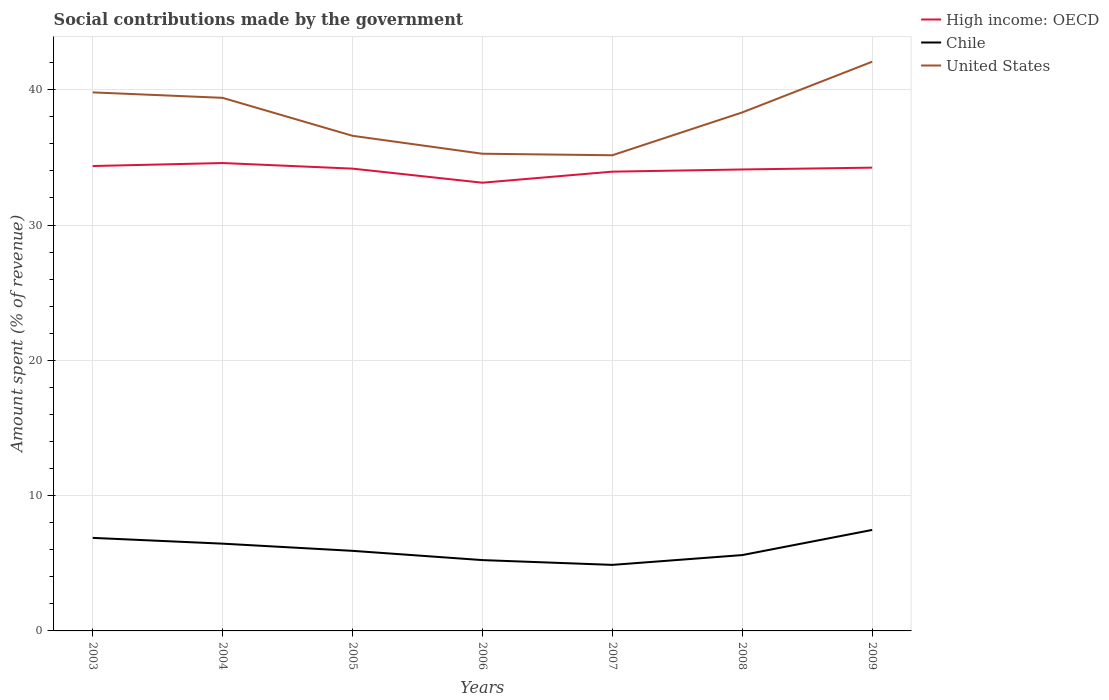Does the line corresponding to United States intersect with the line corresponding to Chile?
Offer a terse response. No. Is the number of lines equal to the number of legend labels?
Offer a terse response. Yes. Across all years, what is the maximum amount spent (in %) on social contributions in United States?
Ensure brevity in your answer.  35.16. In which year was the amount spent (in %) on social contributions in United States maximum?
Give a very brief answer. 2007. What is the total amount spent (in %) on social contributions in High income: OECD in the graph?
Give a very brief answer. 0.42. What is the difference between the highest and the second highest amount spent (in %) on social contributions in United States?
Keep it short and to the point. 6.91. What is the difference between the highest and the lowest amount spent (in %) on social contributions in High income: OECD?
Your answer should be compact. 5. Is the amount spent (in %) on social contributions in Chile strictly greater than the amount spent (in %) on social contributions in High income: OECD over the years?
Your response must be concise. Yes. How many lines are there?
Provide a succinct answer. 3. How many years are there in the graph?
Make the answer very short. 7. What is the difference between two consecutive major ticks on the Y-axis?
Provide a succinct answer. 10. Are the values on the major ticks of Y-axis written in scientific E-notation?
Your answer should be very brief. No. Does the graph contain any zero values?
Your answer should be very brief. No. How are the legend labels stacked?
Offer a very short reply. Vertical. What is the title of the graph?
Provide a succinct answer. Social contributions made by the government. Does "Ghana" appear as one of the legend labels in the graph?
Ensure brevity in your answer.  No. What is the label or title of the Y-axis?
Provide a short and direct response. Amount spent (% of revenue). What is the Amount spent (% of revenue) of High income: OECD in 2003?
Give a very brief answer. 34.36. What is the Amount spent (% of revenue) in Chile in 2003?
Offer a terse response. 6.88. What is the Amount spent (% of revenue) in United States in 2003?
Offer a very short reply. 39.8. What is the Amount spent (% of revenue) in High income: OECD in 2004?
Give a very brief answer. 34.58. What is the Amount spent (% of revenue) of Chile in 2004?
Offer a very short reply. 6.45. What is the Amount spent (% of revenue) in United States in 2004?
Offer a terse response. 39.4. What is the Amount spent (% of revenue) in High income: OECD in 2005?
Your answer should be very brief. 34.17. What is the Amount spent (% of revenue) in Chile in 2005?
Your response must be concise. 5.92. What is the Amount spent (% of revenue) of United States in 2005?
Make the answer very short. 36.59. What is the Amount spent (% of revenue) of High income: OECD in 2006?
Make the answer very short. 33.13. What is the Amount spent (% of revenue) of Chile in 2006?
Ensure brevity in your answer.  5.23. What is the Amount spent (% of revenue) of United States in 2006?
Make the answer very short. 35.27. What is the Amount spent (% of revenue) of High income: OECD in 2007?
Your answer should be compact. 33.94. What is the Amount spent (% of revenue) in Chile in 2007?
Ensure brevity in your answer.  4.88. What is the Amount spent (% of revenue) in United States in 2007?
Ensure brevity in your answer.  35.16. What is the Amount spent (% of revenue) of High income: OECD in 2008?
Your answer should be compact. 34.1. What is the Amount spent (% of revenue) in Chile in 2008?
Offer a terse response. 5.61. What is the Amount spent (% of revenue) of United States in 2008?
Your answer should be very brief. 38.32. What is the Amount spent (% of revenue) of High income: OECD in 2009?
Make the answer very short. 34.24. What is the Amount spent (% of revenue) of Chile in 2009?
Keep it short and to the point. 7.46. What is the Amount spent (% of revenue) of United States in 2009?
Ensure brevity in your answer.  42.07. Across all years, what is the maximum Amount spent (% of revenue) in High income: OECD?
Offer a terse response. 34.58. Across all years, what is the maximum Amount spent (% of revenue) in Chile?
Ensure brevity in your answer.  7.46. Across all years, what is the maximum Amount spent (% of revenue) in United States?
Provide a short and direct response. 42.07. Across all years, what is the minimum Amount spent (% of revenue) in High income: OECD?
Your answer should be compact. 33.13. Across all years, what is the minimum Amount spent (% of revenue) of Chile?
Offer a very short reply. 4.88. Across all years, what is the minimum Amount spent (% of revenue) of United States?
Provide a short and direct response. 35.16. What is the total Amount spent (% of revenue) of High income: OECD in the graph?
Give a very brief answer. 238.52. What is the total Amount spent (% of revenue) in Chile in the graph?
Keep it short and to the point. 42.43. What is the total Amount spent (% of revenue) of United States in the graph?
Your answer should be very brief. 266.6. What is the difference between the Amount spent (% of revenue) of High income: OECD in 2003 and that in 2004?
Offer a terse response. -0.22. What is the difference between the Amount spent (% of revenue) of Chile in 2003 and that in 2004?
Provide a short and direct response. 0.43. What is the difference between the Amount spent (% of revenue) in United States in 2003 and that in 2004?
Make the answer very short. 0.4. What is the difference between the Amount spent (% of revenue) of High income: OECD in 2003 and that in 2005?
Provide a succinct answer. 0.19. What is the difference between the Amount spent (% of revenue) in Chile in 2003 and that in 2005?
Provide a short and direct response. 0.96. What is the difference between the Amount spent (% of revenue) in United States in 2003 and that in 2005?
Give a very brief answer. 3.21. What is the difference between the Amount spent (% of revenue) in High income: OECD in 2003 and that in 2006?
Your response must be concise. 1.23. What is the difference between the Amount spent (% of revenue) of Chile in 2003 and that in 2006?
Your answer should be compact. 1.64. What is the difference between the Amount spent (% of revenue) of United States in 2003 and that in 2006?
Your response must be concise. 4.53. What is the difference between the Amount spent (% of revenue) of High income: OECD in 2003 and that in 2007?
Provide a succinct answer. 0.42. What is the difference between the Amount spent (% of revenue) of Chile in 2003 and that in 2007?
Your response must be concise. 2. What is the difference between the Amount spent (% of revenue) of United States in 2003 and that in 2007?
Your response must be concise. 4.65. What is the difference between the Amount spent (% of revenue) of High income: OECD in 2003 and that in 2008?
Make the answer very short. 0.25. What is the difference between the Amount spent (% of revenue) in Chile in 2003 and that in 2008?
Make the answer very short. 1.27. What is the difference between the Amount spent (% of revenue) in United States in 2003 and that in 2008?
Provide a succinct answer. 1.48. What is the difference between the Amount spent (% of revenue) of High income: OECD in 2003 and that in 2009?
Give a very brief answer. 0.12. What is the difference between the Amount spent (% of revenue) in Chile in 2003 and that in 2009?
Provide a succinct answer. -0.59. What is the difference between the Amount spent (% of revenue) in United States in 2003 and that in 2009?
Offer a terse response. -2.27. What is the difference between the Amount spent (% of revenue) in High income: OECD in 2004 and that in 2005?
Give a very brief answer. 0.41. What is the difference between the Amount spent (% of revenue) of Chile in 2004 and that in 2005?
Your answer should be very brief. 0.53. What is the difference between the Amount spent (% of revenue) in United States in 2004 and that in 2005?
Your response must be concise. 2.81. What is the difference between the Amount spent (% of revenue) in High income: OECD in 2004 and that in 2006?
Give a very brief answer. 1.45. What is the difference between the Amount spent (% of revenue) in Chile in 2004 and that in 2006?
Provide a short and direct response. 1.22. What is the difference between the Amount spent (% of revenue) of United States in 2004 and that in 2006?
Offer a very short reply. 4.13. What is the difference between the Amount spent (% of revenue) of High income: OECD in 2004 and that in 2007?
Your response must be concise. 0.64. What is the difference between the Amount spent (% of revenue) in Chile in 2004 and that in 2007?
Keep it short and to the point. 1.57. What is the difference between the Amount spent (% of revenue) in United States in 2004 and that in 2007?
Your answer should be very brief. 4.24. What is the difference between the Amount spent (% of revenue) in High income: OECD in 2004 and that in 2008?
Provide a short and direct response. 0.48. What is the difference between the Amount spent (% of revenue) of Chile in 2004 and that in 2008?
Keep it short and to the point. 0.84. What is the difference between the Amount spent (% of revenue) of United States in 2004 and that in 2008?
Your answer should be compact. 1.08. What is the difference between the Amount spent (% of revenue) in High income: OECD in 2004 and that in 2009?
Give a very brief answer. 0.34. What is the difference between the Amount spent (% of revenue) of Chile in 2004 and that in 2009?
Make the answer very short. -1.01. What is the difference between the Amount spent (% of revenue) in United States in 2004 and that in 2009?
Your response must be concise. -2.67. What is the difference between the Amount spent (% of revenue) of High income: OECD in 2005 and that in 2006?
Offer a terse response. 1.04. What is the difference between the Amount spent (% of revenue) of Chile in 2005 and that in 2006?
Offer a terse response. 0.68. What is the difference between the Amount spent (% of revenue) of United States in 2005 and that in 2006?
Give a very brief answer. 1.33. What is the difference between the Amount spent (% of revenue) of High income: OECD in 2005 and that in 2007?
Your answer should be compact. 0.22. What is the difference between the Amount spent (% of revenue) in Chile in 2005 and that in 2007?
Make the answer very short. 1.04. What is the difference between the Amount spent (% of revenue) in United States in 2005 and that in 2007?
Give a very brief answer. 1.44. What is the difference between the Amount spent (% of revenue) of High income: OECD in 2005 and that in 2008?
Provide a short and direct response. 0.06. What is the difference between the Amount spent (% of revenue) in Chile in 2005 and that in 2008?
Provide a short and direct response. 0.31. What is the difference between the Amount spent (% of revenue) in United States in 2005 and that in 2008?
Offer a terse response. -1.73. What is the difference between the Amount spent (% of revenue) in High income: OECD in 2005 and that in 2009?
Your answer should be very brief. -0.07. What is the difference between the Amount spent (% of revenue) of Chile in 2005 and that in 2009?
Give a very brief answer. -1.54. What is the difference between the Amount spent (% of revenue) in United States in 2005 and that in 2009?
Ensure brevity in your answer.  -5.47. What is the difference between the Amount spent (% of revenue) of High income: OECD in 2006 and that in 2007?
Provide a succinct answer. -0.82. What is the difference between the Amount spent (% of revenue) in Chile in 2006 and that in 2007?
Your answer should be very brief. 0.35. What is the difference between the Amount spent (% of revenue) of United States in 2006 and that in 2007?
Your response must be concise. 0.11. What is the difference between the Amount spent (% of revenue) in High income: OECD in 2006 and that in 2008?
Offer a terse response. -0.98. What is the difference between the Amount spent (% of revenue) of Chile in 2006 and that in 2008?
Offer a terse response. -0.37. What is the difference between the Amount spent (% of revenue) of United States in 2006 and that in 2008?
Ensure brevity in your answer.  -3.05. What is the difference between the Amount spent (% of revenue) of High income: OECD in 2006 and that in 2009?
Your answer should be very brief. -1.11. What is the difference between the Amount spent (% of revenue) in Chile in 2006 and that in 2009?
Ensure brevity in your answer.  -2.23. What is the difference between the Amount spent (% of revenue) in United States in 2006 and that in 2009?
Offer a very short reply. -6.8. What is the difference between the Amount spent (% of revenue) in High income: OECD in 2007 and that in 2008?
Your response must be concise. -0.16. What is the difference between the Amount spent (% of revenue) of Chile in 2007 and that in 2008?
Your answer should be compact. -0.72. What is the difference between the Amount spent (% of revenue) of United States in 2007 and that in 2008?
Offer a terse response. -3.16. What is the difference between the Amount spent (% of revenue) of High income: OECD in 2007 and that in 2009?
Provide a succinct answer. -0.3. What is the difference between the Amount spent (% of revenue) in Chile in 2007 and that in 2009?
Give a very brief answer. -2.58. What is the difference between the Amount spent (% of revenue) in United States in 2007 and that in 2009?
Offer a very short reply. -6.91. What is the difference between the Amount spent (% of revenue) in High income: OECD in 2008 and that in 2009?
Your answer should be compact. -0.13. What is the difference between the Amount spent (% of revenue) in Chile in 2008 and that in 2009?
Ensure brevity in your answer.  -1.86. What is the difference between the Amount spent (% of revenue) in United States in 2008 and that in 2009?
Provide a succinct answer. -3.75. What is the difference between the Amount spent (% of revenue) in High income: OECD in 2003 and the Amount spent (% of revenue) in Chile in 2004?
Your response must be concise. 27.91. What is the difference between the Amount spent (% of revenue) in High income: OECD in 2003 and the Amount spent (% of revenue) in United States in 2004?
Your response must be concise. -5.04. What is the difference between the Amount spent (% of revenue) in Chile in 2003 and the Amount spent (% of revenue) in United States in 2004?
Give a very brief answer. -32.52. What is the difference between the Amount spent (% of revenue) of High income: OECD in 2003 and the Amount spent (% of revenue) of Chile in 2005?
Your answer should be very brief. 28.44. What is the difference between the Amount spent (% of revenue) of High income: OECD in 2003 and the Amount spent (% of revenue) of United States in 2005?
Provide a succinct answer. -2.23. What is the difference between the Amount spent (% of revenue) in Chile in 2003 and the Amount spent (% of revenue) in United States in 2005?
Ensure brevity in your answer.  -29.72. What is the difference between the Amount spent (% of revenue) in High income: OECD in 2003 and the Amount spent (% of revenue) in Chile in 2006?
Offer a very short reply. 29.12. What is the difference between the Amount spent (% of revenue) in High income: OECD in 2003 and the Amount spent (% of revenue) in United States in 2006?
Provide a succinct answer. -0.91. What is the difference between the Amount spent (% of revenue) of Chile in 2003 and the Amount spent (% of revenue) of United States in 2006?
Make the answer very short. -28.39. What is the difference between the Amount spent (% of revenue) of High income: OECD in 2003 and the Amount spent (% of revenue) of Chile in 2007?
Offer a terse response. 29.48. What is the difference between the Amount spent (% of revenue) of High income: OECD in 2003 and the Amount spent (% of revenue) of United States in 2007?
Your answer should be compact. -0.8. What is the difference between the Amount spent (% of revenue) in Chile in 2003 and the Amount spent (% of revenue) in United States in 2007?
Your response must be concise. -28.28. What is the difference between the Amount spent (% of revenue) of High income: OECD in 2003 and the Amount spent (% of revenue) of Chile in 2008?
Offer a terse response. 28.75. What is the difference between the Amount spent (% of revenue) in High income: OECD in 2003 and the Amount spent (% of revenue) in United States in 2008?
Offer a terse response. -3.96. What is the difference between the Amount spent (% of revenue) in Chile in 2003 and the Amount spent (% of revenue) in United States in 2008?
Your response must be concise. -31.44. What is the difference between the Amount spent (% of revenue) in High income: OECD in 2003 and the Amount spent (% of revenue) in Chile in 2009?
Keep it short and to the point. 26.89. What is the difference between the Amount spent (% of revenue) of High income: OECD in 2003 and the Amount spent (% of revenue) of United States in 2009?
Provide a short and direct response. -7.71. What is the difference between the Amount spent (% of revenue) of Chile in 2003 and the Amount spent (% of revenue) of United States in 2009?
Ensure brevity in your answer.  -35.19. What is the difference between the Amount spent (% of revenue) in High income: OECD in 2004 and the Amount spent (% of revenue) in Chile in 2005?
Your answer should be very brief. 28.66. What is the difference between the Amount spent (% of revenue) of High income: OECD in 2004 and the Amount spent (% of revenue) of United States in 2005?
Keep it short and to the point. -2.01. What is the difference between the Amount spent (% of revenue) of Chile in 2004 and the Amount spent (% of revenue) of United States in 2005?
Keep it short and to the point. -30.14. What is the difference between the Amount spent (% of revenue) of High income: OECD in 2004 and the Amount spent (% of revenue) of Chile in 2006?
Make the answer very short. 29.35. What is the difference between the Amount spent (% of revenue) in High income: OECD in 2004 and the Amount spent (% of revenue) in United States in 2006?
Your response must be concise. -0.69. What is the difference between the Amount spent (% of revenue) in Chile in 2004 and the Amount spent (% of revenue) in United States in 2006?
Keep it short and to the point. -28.82. What is the difference between the Amount spent (% of revenue) in High income: OECD in 2004 and the Amount spent (% of revenue) in Chile in 2007?
Your response must be concise. 29.7. What is the difference between the Amount spent (% of revenue) in High income: OECD in 2004 and the Amount spent (% of revenue) in United States in 2007?
Ensure brevity in your answer.  -0.57. What is the difference between the Amount spent (% of revenue) in Chile in 2004 and the Amount spent (% of revenue) in United States in 2007?
Provide a succinct answer. -28.71. What is the difference between the Amount spent (% of revenue) of High income: OECD in 2004 and the Amount spent (% of revenue) of Chile in 2008?
Provide a short and direct response. 28.97. What is the difference between the Amount spent (% of revenue) in High income: OECD in 2004 and the Amount spent (% of revenue) in United States in 2008?
Ensure brevity in your answer.  -3.74. What is the difference between the Amount spent (% of revenue) in Chile in 2004 and the Amount spent (% of revenue) in United States in 2008?
Your answer should be compact. -31.87. What is the difference between the Amount spent (% of revenue) in High income: OECD in 2004 and the Amount spent (% of revenue) in Chile in 2009?
Make the answer very short. 27.12. What is the difference between the Amount spent (% of revenue) in High income: OECD in 2004 and the Amount spent (% of revenue) in United States in 2009?
Your answer should be very brief. -7.49. What is the difference between the Amount spent (% of revenue) of Chile in 2004 and the Amount spent (% of revenue) of United States in 2009?
Keep it short and to the point. -35.62. What is the difference between the Amount spent (% of revenue) of High income: OECD in 2005 and the Amount spent (% of revenue) of Chile in 2006?
Offer a very short reply. 28.93. What is the difference between the Amount spent (% of revenue) in High income: OECD in 2005 and the Amount spent (% of revenue) in United States in 2006?
Your response must be concise. -1.1. What is the difference between the Amount spent (% of revenue) of Chile in 2005 and the Amount spent (% of revenue) of United States in 2006?
Provide a short and direct response. -29.35. What is the difference between the Amount spent (% of revenue) of High income: OECD in 2005 and the Amount spent (% of revenue) of Chile in 2007?
Your answer should be compact. 29.29. What is the difference between the Amount spent (% of revenue) of High income: OECD in 2005 and the Amount spent (% of revenue) of United States in 2007?
Make the answer very short. -0.99. What is the difference between the Amount spent (% of revenue) of Chile in 2005 and the Amount spent (% of revenue) of United States in 2007?
Offer a terse response. -29.24. What is the difference between the Amount spent (% of revenue) of High income: OECD in 2005 and the Amount spent (% of revenue) of Chile in 2008?
Offer a terse response. 28.56. What is the difference between the Amount spent (% of revenue) of High income: OECD in 2005 and the Amount spent (% of revenue) of United States in 2008?
Give a very brief answer. -4.15. What is the difference between the Amount spent (% of revenue) of Chile in 2005 and the Amount spent (% of revenue) of United States in 2008?
Make the answer very short. -32.4. What is the difference between the Amount spent (% of revenue) in High income: OECD in 2005 and the Amount spent (% of revenue) in Chile in 2009?
Offer a terse response. 26.7. What is the difference between the Amount spent (% of revenue) of High income: OECD in 2005 and the Amount spent (% of revenue) of United States in 2009?
Offer a very short reply. -7.9. What is the difference between the Amount spent (% of revenue) of Chile in 2005 and the Amount spent (% of revenue) of United States in 2009?
Ensure brevity in your answer.  -36.15. What is the difference between the Amount spent (% of revenue) of High income: OECD in 2006 and the Amount spent (% of revenue) of Chile in 2007?
Provide a succinct answer. 28.25. What is the difference between the Amount spent (% of revenue) of High income: OECD in 2006 and the Amount spent (% of revenue) of United States in 2007?
Provide a short and direct response. -2.03. What is the difference between the Amount spent (% of revenue) in Chile in 2006 and the Amount spent (% of revenue) in United States in 2007?
Offer a terse response. -29.92. What is the difference between the Amount spent (% of revenue) of High income: OECD in 2006 and the Amount spent (% of revenue) of Chile in 2008?
Give a very brief answer. 27.52. What is the difference between the Amount spent (% of revenue) in High income: OECD in 2006 and the Amount spent (% of revenue) in United States in 2008?
Your response must be concise. -5.19. What is the difference between the Amount spent (% of revenue) in Chile in 2006 and the Amount spent (% of revenue) in United States in 2008?
Keep it short and to the point. -33.09. What is the difference between the Amount spent (% of revenue) in High income: OECD in 2006 and the Amount spent (% of revenue) in Chile in 2009?
Keep it short and to the point. 25.66. What is the difference between the Amount spent (% of revenue) in High income: OECD in 2006 and the Amount spent (% of revenue) in United States in 2009?
Your response must be concise. -8.94. What is the difference between the Amount spent (% of revenue) of Chile in 2006 and the Amount spent (% of revenue) of United States in 2009?
Your answer should be compact. -36.83. What is the difference between the Amount spent (% of revenue) in High income: OECD in 2007 and the Amount spent (% of revenue) in Chile in 2008?
Offer a terse response. 28.34. What is the difference between the Amount spent (% of revenue) in High income: OECD in 2007 and the Amount spent (% of revenue) in United States in 2008?
Your response must be concise. -4.38. What is the difference between the Amount spent (% of revenue) of Chile in 2007 and the Amount spent (% of revenue) of United States in 2008?
Your response must be concise. -33.44. What is the difference between the Amount spent (% of revenue) of High income: OECD in 2007 and the Amount spent (% of revenue) of Chile in 2009?
Make the answer very short. 26.48. What is the difference between the Amount spent (% of revenue) in High income: OECD in 2007 and the Amount spent (% of revenue) in United States in 2009?
Make the answer very short. -8.12. What is the difference between the Amount spent (% of revenue) in Chile in 2007 and the Amount spent (% of revenue) in United States in 2009?
Your answer should be very brief. -37.19. What is the difference between the Amount spent (% of revenue) of High income: OECD in 2008 and the Amount spent (% of revenue) of Chile in 2009?
Make the answer very short. 26.64. What is the difference between the Amount spent (% of revenue) of High income: OECD in 2008 and the Amount spent (% of revenue) of United States in 2009?
Your answer should be very brief. -7.96. What is the difference between the Amount spent (% of revenue) in Chile in 2008 and the Amount spent (% of revenue) in United States in 2009?
Your answer should be very brief. -36.46. What is the average Amount spent (% of revenue) in High income: OECD per year?
Provide a succinct answer. 34.07. What is the average Amount spent (% of revenue) of Chile per year?
Your answer should be compact. 6.06. What is the average Amount spent (% of revenue) in United States per year?
Your answer should be compact. 38.09. In the year 2003, what is the difference between the Amount spent (% of revenue) in High income: OECD and Amount spent (% of revenue) in Chile?
Ensure brevity in your answer.  27.48. In the year 2003, what is the difference between the Amount spent (% of revenue) in High income: OECD and Amount spent (% of revenue) in United States?
Offer a terse response. -5.44. In the year 2003, what is the difference between the Amount spent (% of revenue) of Chile and Amount spent (% of revenue) of United States?
Provide a succinct answer. -32.93. In the year 2004, what is the difference between the Amount spent (% of revenue) of High income: OECD and Amount spent (% of revenue) of Chile?
Offer a very short reply. 28.13. In the year 2004, what is the difference between the Amount spent (% of revenue) of High income: OECD and Amount spent (% of revenue) of United States?
Your response must be concise. -4.82. In the year 2004, what is the difference between the Amount spent (% of revenue) in Chile and Amount spent (% of revenue) in United States?
Keep it short and to the point. -32.95. In the year 2005, what is the difference between the Amount spent (% of revenue) in High income: OECD and Amount spent (% of revenue) in Chile?
Provide a succinct answer. 28.25. In the year 2005, what is the difference between the Amount spent (% of revenue) in High income: OECD and Amount spent (% of revenue) in United States?
Ensure brevity in your answer.  -2.43. In the year 2005, what is the difference between the Amount spent (% of revenue) in Chile and Amount spent (% of revenue) in United States?
Ensure brevity in your answer.  -30.67. In the year 2006, what is the difference between the Amount spent (% of revenue) of High income: OECD and Amount spent (% of revenue) of Chile?
Your response must be concise. 27.89. In the year 2006, what is the difference between the Amount spent (% of revenue) in High income: OECD and Amount spent (% of revenue) in United States?
Your answer should be very brief. -2.14. In the year 2006, what is the difference between the Amount spent (% of revenue) in Chile and Amount spent (% of revenue) in United States?
Make the answer very short. -30.03. In the year 2007, what is the difference between the Amount spent (% of revenue) in High income: OECD and Amount spent (% of revenue) in Chile?
Provide a succinct answer. 29.06. In the year 2007, what is the difference between the Amount spent (% of revenue) in High income: OECD and Amount spent (% of revenue) in United States?
Provide a succinct answer. -1.21. In the year 2007, what is the difference between the Amount spent (% of revenue) in Chile and Amount spent (% of revenue) in United States?
Provide a succinct answer. -30.27. In the year 2008, what is the difference between the Amount spent (% of revenue) in High income: OECD and Amount spent (% of revenue) in Chile?
Offer a very short reply. 28.5. In the year 2008, what is the difference between the Amount spent (% of revenue) in High income: OECD and Amount spent (% of revenue) in United States?
Provide a short and direct response. -4.21. In the year 2008, what is the difference between the Amount spent (% of revenue) of Chile and Amount spent (% of revenue) of United States?
Give a very brief answer. -32.71. In the year 2009, what is the difference between the Amount spent (% of revenue) of High income: OECD and Amount spent (% of revenue) of Chile?
Your answer should be very brief. 26.78. In the year 2009, what is the difference between the Amount spent (% of revenue) in High income: OECD and Amount spent (% of revenue) in United States?
Give a very brief answer. -7.83. In the year 2009, what is the difference between the Amount spent (% of revenue) of Chile and Amount spent (% of revenue) of United States?
Keep it short and to the point. -34.6. What is the ratio of the Amount spent (% of revenue) of High income: OECD in 2003 to that in 2004?
Your answer should be compact. 0.99. What is the ratio of the Amount spent (% of revenue) of Chile in 2003 to that in 2004?
Provide a short and direct response. 1.07. What is the ratio of the Amount spent (% of revenue) in United States in 2003 to that in 2004?
Your response must be concise. 1.01. What is the ratio of the Amount spent (% of revenue) in High income: OECD in 2003 to that in 2005?
Give a very brief answer. 1.01. What is the ratio of the Amount spent (% of revenue) of Chile in 2003 to that in 2005?
Your answer should be very brief. 1.16. What is the ratio of the Amount spent (% of revenue) of United States in 2003 to that in 2005?
Offer a very short reply. 1.09. What is the ratio of the Amount spent (% of revenue) of High income: OECD in 2003 to that in 2006?
Provide a short and direct response. 1.04. What is the ratio of the Amount spent (% of revenue) in Chile in 2003 to that in 2006?
Your answer should be very brief. 1.31. What is the ratio of the Amount spent (% of revenue) in United States in 2003 to that in 2006?
Offer a terse response. 1.13. What is the ratio of the Amount spent (% of revenue) in High income: OECD in 2003 to that in 2007?
Offer a very short reply. 1.01. What is the ratio of the Amount spent (% of revenue) in Chile in 2003 to that in 2007?
Provide a succinct answer. 1.41. What is the ratio of the Amount spent (% of revenue) in United States in 2003 to that in 2007?
Provide a short and direct response. 1.13. What is the ratio of the Amount spent (% of revenue) of High income: OECD in 2003 to that in 2008?
Provide a short and direct response. 1.01. What is the ratio of the Amount spent (% of revenue) in Chile in 2003 to that in 2008?
Your answer should be compact. 1.23. What is the ratio of the Amount spent (% of revenue) of United States in 2003 to that in 2008?
Provide a succinct answer. 1.04. What is the ratio of the Amount spent (% of revenue) in High income: OECD in 2003 to that in 2009?
Offer a very short reply. 1. What is the ratio of the Amount spent (% of revenue) of Chile in 2003 to that in 2009?
Your answer should be very brief. 0.92. What is the ratio of the Amount spent (% of revenue) of United States in 2003 to that in 2009?
Keep it short and to the point. 0.95. What is the ratio of the Amount spent (% of revenue) of High income: OECD in 2004 to that in 2005?
Provide a succinct answer. 1.01. What is the ratio of the Amount spent (% of revenue) of Chile in 2004 to that in 2005?
Give a very brief answer. 1.09. What is the ratio of the Amount spent (% of revenue) of United States in 2004 to that in 2005?
Your response must be concise. 1.08. What is the ratio of the Amount spent (% of revenue) of High income: OECD in 2004 to that in 2006?
Offer a terse response. 1.04. What is the ratio of the Amount spent (% of revenue) of Chile in 2004 to that in 2006?
Give a very brief answer. 1.23. What is the ratio of the Amount spent (% of revenue) of United States in 2004 to that in 2006?
Provide a succinct answer. 1.12. What is the ratio of the Amount spent (% of revenue) of High income: OECD in 2004 to that in 2007?
Give a very brief answer. 1.02. What is the ratio of the Amount spent (% of revenue) in Chile in 2004 to that in 2007?
Provide a short and direct response. 1.32. What is the ratio of the Amount spent (% of revenue) in United States in 2004 to that in 2007?
Give a very brief answer. 1.12. What is the ratio of the Amount spent (% of revenue) in High income: OECD in 2004 to that in 2008?
Provide a short and direct response. 1.01. What is the ratio of the Amount spent (% of revenue) of Chile in 2004 to that in 2008?
Offer a very short reply. 1.15. What is the ratio of the Amount spent (% of revenue) in United States in 2004 to that in 2008?
Your response must be concise. 1.03. What is the ratio of the Amount spent (% of revenue) in High income: OECD in 2004 to that in 2009?
Make the answer very short. 1.01. What is the ratio of the Amount spent (% of revenue) of Chile in 2004 to that in 2009?
Offer a very short reply. 0.86. What is the ratio of the Amount spent (% of revenue) in United States in 2004 to that in 2009?
Offer a very short reply. 0.94. What is the ratio of the Amount spent (% of revenue) of High income: OECD in 2005 to that in 2006?
Give a very brief answer. 1.03. What is the ratio of the Amount spent (% of revenue) in Chile in 2005 to that in 2006?
Make the answer very short. 1.13. What is the ratio of the Amount spent (% of revenue) in United States in 2005 to that in 2006?
Your answer should be compact. 1.04. What is the ratio of the Amount spent (% of revenue) in High income: OECD in 2005 to that in 2007?
Your answer should be compact. 1.01. What is the ratio of the Amount spent (% of revenue) in Chile in 2005 to that in 2007?
Make the answer very short. 1.21. What is the ratio of the Amount spent (% of revenue) of United States in 2005 to that in 2007?
Give a very brief answer. 1.04. What is the ratio of the Amount spent (% of revenue) of High income: OECD in 2005 to that in 2008?
Keep it short and to the point. 1. What is the ratio of the Amount spent (% of revenue) in Chile in 2005 to that in 2008?
Offer a terse response. 1.06. What is the ratio of the Amount spent (% of revenue) of United States in 2005 to that in 2008?
Provide a succinct answer. 0.95. What is the ratio of the Amount spent (% of revenue) in High income: OECD in 2005 to that in 2009?
Make the answer very short. 1. What is the ratio of the Amount spent (% of revenue) of Chile in 2005 to that in 2009?
Your answer should be compact. 0.79. What is the ratio of the Amount spent (% of revenue) in United States in 2005 to that in 2009?
Offer a very short reply. 0.87. What is the ratio of the Amount spent (% of revenue) of High income: OECD in 2006 to that in 2007?
Make the answer very short. 0.98. What is the ratio of the Amount spent (% of revenue) of Chile in 2006 to that in 2007?
Keep it short and to the point. 1.07. What is the ratio of the Amount spent (% of revenue) in United States in 2006 to that in 2007?
Your response must be concise. 1. What is the ratio of the Amount spent (% of revenue) in High income: OECD in 2006 to that in 2008?
Provide a succinct answer. 0.97. What is the ratio of the Amount spent (% of revenue) in Chile in 2006 to that in 2008?
Keep it short and to the point. 0.93. What is the ratio of the Amount spent (% of revenue) of United States in 2006 to that in 2008?
Offer a terse response. 0.92. What is the ratio of the Amount spent (% of revenue) in High income: OECD in 2006 to that in 2009?
Ensure brevity in your answer.  0.97. What is the ratio of the Amount spent (% of revenue) of Chile in 2006 to that in 2009?
Your response must be concise. 0.7. What is the ratio of the Amount spent (% of revenue) in United States in 2006 to that in 2009?
Provide a short and direct response. 0.84. What is the ratio of the Amount spent (% of revenue) of Chile in 2007 to that in 2008?
Give a very brief answer. 0.87. What is the ratio of the Amount spent (% of revenue) of United States in 2007 to that in 2008?
Keep it short and to the point. 0.92. What is the ratio of the Amount spent (% of revenue) in High income: OECD in 2007 to that in 2009?
Your response must be concise. 0.99. What is the ratio of the Amount spent (% of revenue) in Chile in 2007 to that in 2009?
Your response must be concise. 0.65. What is the ratio of the Amount spent (% of revenue) of United States in 2007 to that in 2009?
Your answer should be very brief. 0.84. What is the ratio of the Amount spent (% of revenue) of Chile in 2008 to that in 2009?
Your answer should be very brief. 0.75. What is the ratio of the Amount spent (% of revenue) of United States in 2008 to that in 2009?
Your answer should be compact. 0.91. What is the difference between the highest and the second highest Amount spent (% of revenue) of High income: OECD?
Offer a very short reply. 0.22. What is the difference between the highest and the second highest Amount spent (% of revenue) of Chile?
Make the answer very short. 0.59. What is the difference between the highest and the second highest Amount spent (% of revenue) in United States?
Provide a succinct answer. 2.27. What is the difference between the highest and the lowest Amount spent (% of revenue) in High income: OECD?
Offer a terse response. 1.45. What is the difference between the highest and the lowest Amount spent (% of revenue) of Chile?
Ensure brevity in your answer.  2.58. What is the difference between the highest and the lowest Amount spent (% of revenue) of United States?
Your answer should be very brief. 6.91. 